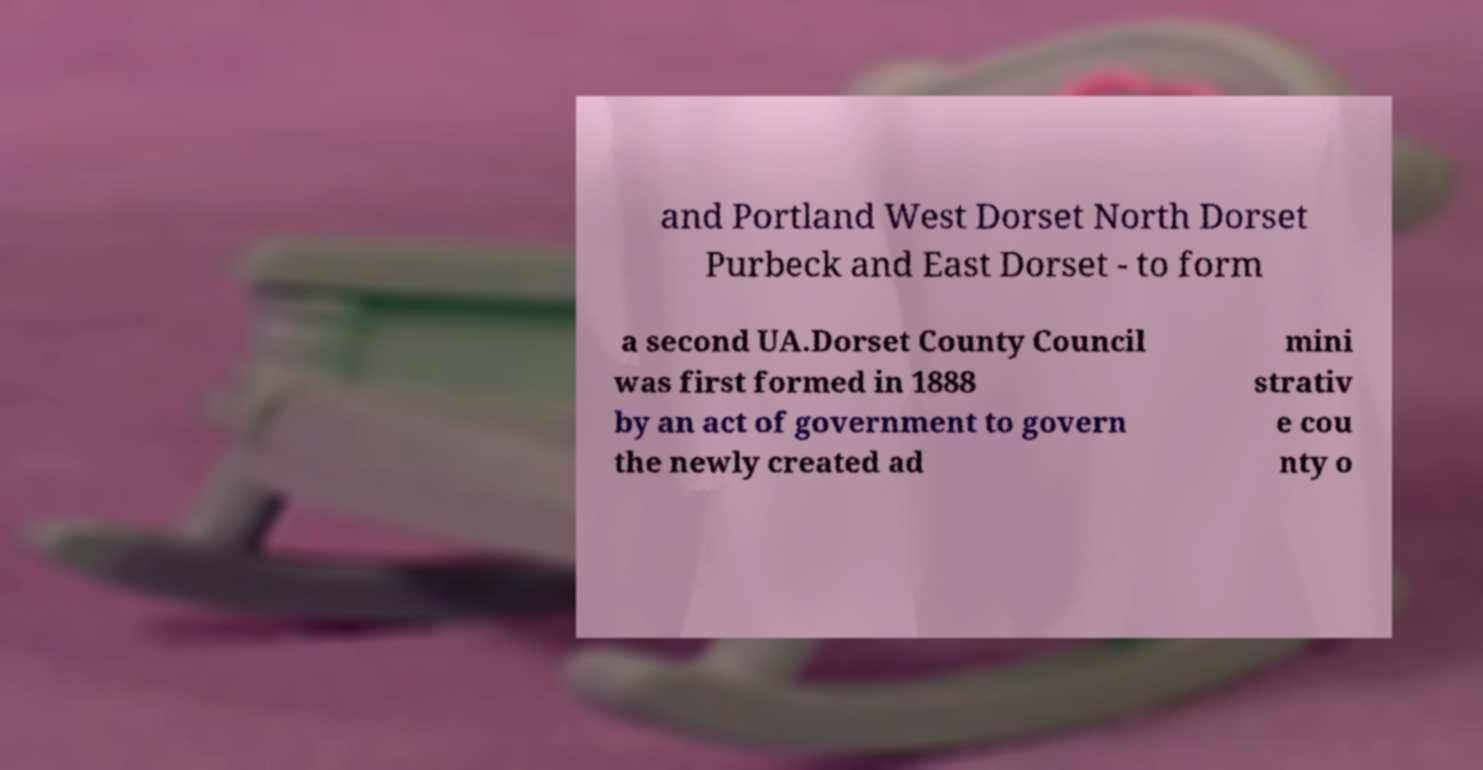Can you accurately transcribe the text from the provided image for me? and Portland West Dorset North Dorset Purbeck and East Dorset - to form a second UA.Dorset County Council was first formed in 1888 by an act of government to govern the newly created ad mini strativ e cou nty o 